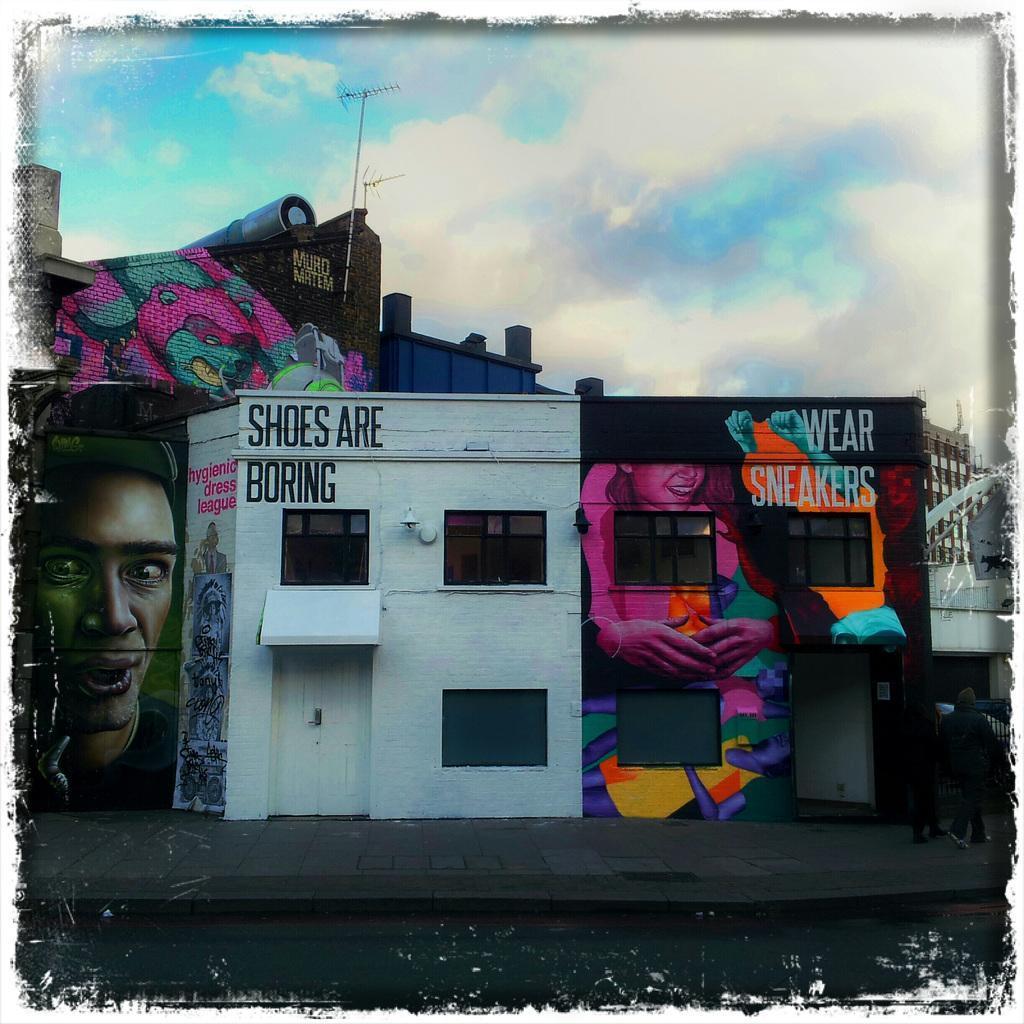Could you give a brief overview of what you see in this image? In this edited image, we can see a building contains some art. There are clouds in the sky. There is a footpath at the bottom of the image. 